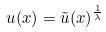<formula> <loc_0><loc_0><loc_500><loc_500>u ( x ) = \tilde { u } ( x ) ^ { \frac { 1 } { \lambda } }</formula> 